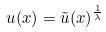<formula> <loc_0><loc_0><loc_500><loc_500>u ( x ) = \tilde { u } ( x ) ^ { \frac { 1 } { \lambda } }</formula> 